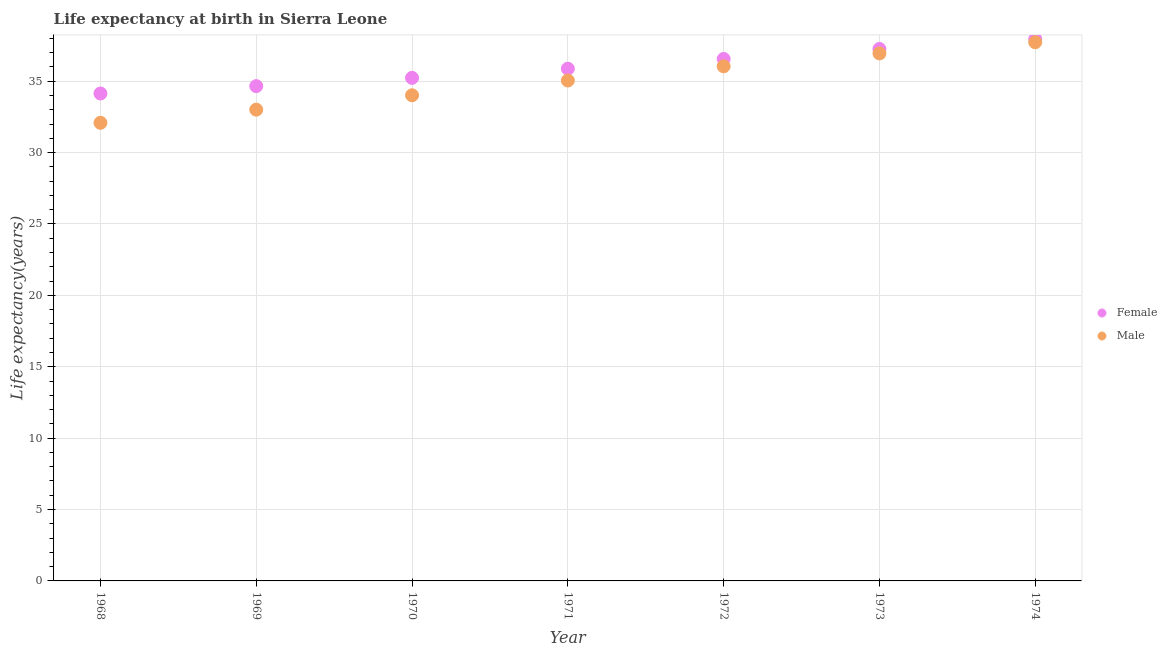What is the life expectancy(female) in 1969?
Give a very brief answer. 34.66. Across all years, what is the maximum life expectancy(male)?
Offer a terse response. 37.73. Across all years, what is the minimum life expectancy(female)?
Make the answer very short. 34.14. In which year was the life expectancy(male) maximum?
Give a very brief answer. 1974. In which year was the life expectancy(male) minimum?
Offer a terse response. 1968. What is the total life expectancy(female) in the graph?
Your answer should be compact. 251.67. What is the difference between the life expectancy(female) in 1968 and that in 1970?
Offer a terse response. -1.1. What is the difference between the life expectancy(male) in 1972 and the life expectancy(female) in 1970?
Offer a very short reply. 0.81. What is the average life expectancy(male) per year?
Offer a terse response. 34.98. In the year 1970, what is the difference between the life expectancy(male) and life expectancy(female)?
Give a very brief answer. -1.22. What is the ratio of the life expectancy(male) in 1968 to that in 1969?
Ensure brevity in your answer.  0.97. Is the life expectancy(female) in 1968 less than that in 1971?
Your response must be concise. Yes. Is the difference between the life expectancy(male) in 1970 and 1971 greater than the difference between the life expectancy(female) in 1970 and 1971?
Offer a terse response. No. What is the difference between the highest and the second highest life expectancy(male)?
Your response must be concise. 0.78. What is the difference between the highest and the lowest life expectancy(male)?
Make the answer very short. 5.64. Is the life expectancy(female) strictly greater than the life expectancy(male) over the years?
Your answer should be very brief. Yes. Is the life expectancy(male) strictly less than the life expectancy(female) over the years?
Give a very brief answer. Yes. How many dotlines are there?
Offer a terse response. 2. How many years are there in the graph?
Provide a succinct answer. 7. Does the graph contain any zero values?
Offer a terse response. No. Does the graph contain grids?
Give a very brief answer. Yes. How are the legend labels stacked?
Ensure brevity in your answer.  Vertical. What is the title of the graph?
Offer a very short reply. Life expectancy at birth in Sierra Leone. What is the label or title of the Y-axis?
Your response must be concise. Life expectancy(years). What is the Life expectancy(years) in Female in 1968?
Give a very brief answer. 34.14. What is the Life expectancy(years) in Male in 1968?
Your answer should be very brief. 32.09. What is the Life expectancy(years) in Female in 1969?
Your response must be concise. 34.66. What is the Life expectancy(years) of Male in 1969?
Provide a short and direct response. 33.01. What is the Life expectancy(years) of Female in 1970?
Provide a succinct answer. 35.23. What is the Life expectancy(years) in Male in 1970?
Your response must be concise. 34.01. What is the Life expectancy(years) of Female in 1971?
Your answer should be compact. 35.88. What is the Life expectancy(years) in Male in 1971?
Your answer should be compact. 35.05. What is the Life expectancy(years) in Female in 1972?
Your answer should be compact. 36.56. What is the Life expectancy(years) in Male in 1972?
Your response must be concise. 36.05. What is the Life expectancy(years) in Female in 1973?
Provide a succinct answer. 37.26. What is the Life expectancy(years) in Male in 1973?
Your answer should be very brief. 36.95. What is the Life expectancy(years) in Female in 1974?
Provide a succinct answer. 37.95. What is the Life expectancy(years) of Male in 1974?
Your answer should be very brief. 37.73. Across all years, what is the maximum Life expectancy(years) of Female?
Provide a short and direct response. 37.95. Across all years, what is the maximum Life expectancy(years) of Male?
Ensure brevity in your answer.  37.73. Across all years, what is the minimum Life expectancy(years) in Female?
Make the answer very short. 34.14. Across all years, what is the minimum Life expectancy(years) in Male?
Offer a terse response. 32.09. What is the total Life expectancy(years) of Female in the graph?
Offer a terse response. 251.67. What is the total Life expectancy(years) in Male in the graph?
Provide a succinct answer. 244.87. What is the difference between the Life expectancy(years) of Female in 1968 and that in 1969?
Offer a terse response. -0.52. What is the difference between the Life expectancy(years) in Male in 1968 and that in 1969?
Offer a terse response. -0.92. What is the difference between the Life expectancy(years) of Female in 1968 and that in 1970?
Your answer should be compact. -1.1. What is the difference between the Life expectancy(years) in Male in 1968 and that in 1970?
Your response must be concise. -1.93. What is the difference between the Life expectancy(years) in Female in 1968 and that in 1971?
Provide a short and direct response. -1.74. What is the difference between the Life expectancy(years) of Male in 1968 and that in 1971?
Make the answer very short. -2.96. What is the difference between the Life expectancy(years) of Female in 1968 and that in 1972?
Offer a terse response. -2.42. What is the difference between the Life expectancy(years) in Male in 1968 and that in 1972?
Ensure brevity in your answer.  -3.96. What is the difference between the Life expectancy(years) of Female in 1968 and that in 1973?
Ensure brevity in your answer.  -3.12. What is the difference between the Life expectancy(years) of Male in 1968 and that in 1973?
Offer a very short reply. -4.86. What is the difference between the Life expectancy(years) of Female in 1968 and that in 1974?
Your response must be concise. -3.81. What is the difference between the Life expectancy(years) in Male in 1968 and that in 1974?
Offer a terse response. -5.64. What is the difference between the Life expectancy(years) of Female in 1969 and that in 1970?
Offer a very short reply. -0.58. What is the difference between the Life expectancy(years) in Male in 1969 and that in 1970?
Give a very brief answer. -1.01. What is the difference between the Life expectancy(years) in Female in 1969 and that in 1971?
Keep it short and to the point. -1.22. What is the difference between the Life expectancy(years) of Male in 1969 and that in 1971?
Give a very brief answer. -2.04. What is the difference between the Life expectancy(years) of Female in 1969 and that in 1972?
Offer a terse response. -1.9. What is the difference between the Life expectancy(years) in Male in 1969 and that in 1972?
Your response must be concise. -3.04. What is the difference between the Life expectancy(years) in Female in 1969 and that in 1973?
Give a very brief answer. -2.6. What is the difference between the Life expectancy(years) of Male in 1969 and that in 1973?
Provide a short and direct response. -3.94. What is the difference between the Life expectancy(years) in Female in 1969 and that in 1974?
Provide a succinct answer. -3.3. What is the difference between the Life expectancy(years) of Male in 1969 and that in 1974?
Your answer should be very brief. -4.72. What is the difference between the Life expectancy(years) in Female in 1970 and that in 1971?
Provide a succinct answer. -0.64. What is the difference between the Life expectancy(years) of Male in 1970 and that in 1971?
Your response must be concise. -1.03. What is the difference between the Life expectancy(years) in Female in 1970 and that in 1972?
Ensure brevity in your answer.  -1.32. What is the difference between the Life expectancy(years) of Male in 1970 and that in 1972?
Offer a very short reply. -2.03. What is the difference between the Life expectancy(years) in Female in 1970 and that in 1973?
Give a very brief answer. -2.02. What is the difference between the Life expectancy(years) in Male in 1970 and that in 1973?
Your answer should be very brief. -2.94. What is the difference between the Life expectancy(years) of Female in 1970 and that in 1974?
Your answer should be very brief. -2.72. What is the difference between the Life expectancy(years) in Male in 1970 and that in 1974?
Your answer should be compact. -3.71. What is the difference between the Life expectancy(years) of Female in 1971 and that in 1972?
Your answer should be compact. -0.68. What is the difference between the Life expectancy(years) of Male in 1971 and that in 1972?
Your response must be concise. -1. What is the difference between the Life expectancy(years) of Female in 1971 and that in 1973?
Your answer should be compact. -1.38. What is the difference between the Life expectancy(years) in Male in 1971 and that in 1973?
Offer a very short reply. -1.9. What is the difference between the Life expectancy(years) of Female in 1971 and that in 1974?
Your answer should be very brief. -2.08. What is the difference between the Life expectancy(years) of Male in 1971 and that in 1974?
Your response must be concise. -2.68. What is the difference between the Life expectancy(years) in Male in 1972 and that in 1973?
Make the answer very short. -0.9. What is the difference between the Life expectancy(years) in Female in 1972 and that in 1974?
Offer a terse response. -1.39. What is the difference between the Life expectancy(years) in Male in 1972 and that in 1974?
Your answer should be very brief. -1.68. What is the difference between the Life expectancy(years) in Female in 1973 and that in 1974?
Ensure brevity in your answer.  -0.69. What is the difference between the Life expectancy(years) of Male in 1973 and that in 1974?
Provide a short and direct response. -0.78. What is the difference between the Life expectancy(years) in Female in 1968 and the Life expectancy(years) in Male in 1969?
Your answer should be compact. 1.13. What is the difference between the Life expectancy(years) in Female in 1968 and the Life expectancy(years) in Male in 1970?
Ensure brevity in your answer.  0.13. What is the difference between the Life expectancy(years) of Female in 1968 and the Life expectancy(years) of Male in 1971?
Provide a short and direct response. -0.91. What is the difference between the Life expectancy(years) in Female in 1968 and the Life expectancy(years) in Male in 1972?
Keep it short and to the point. -1.91. What is the difference between the Life expectancy(years) of Female in 1968 and the Life expectancy(years) of Male in 1973?
Provide a short and direct response. -2.81. What is the difference between the Life expectancy(years) in Female in 1968 and the Life expectancy(years) in Male in 1974?
Provide a succinct answer. -3.59. What is the difference between the Life expectancy(years) in Female in 1969 and the Life expectancy(years) in Male in 1970?
Ensure brevity in your answer.  0.64. What is the difference between the Life expectancy(years) of Female in 1969 and the Life expectancy(years) of Male in 1971?
Your response must be concise. -0.39. What is the difference between the Life expectancy(years) in Female in 1969 and the Life expectancy(years) in Male in 1972?
Your response must be concise. -1.39. What is the difference between the Life expectancy(years) in Female in 1969 and the Life expectancy(years) in Male in 1973?
Provide a succinct answer. -2.29. What is the difference between the Life expectancy(years) of Female in 1969 and the Life expectancy(years) of Male in 1974?
Make the answer very short. -3.07. What is the difference between the Life expectancy(years) in Female in 1970 and the Life expectancy(years) in Male in 1971?
Offer a very short reply. 0.19. What is the difference between the Life expectancy(years) in Female in 1970 and the Life expectancy(years) in Male in 1972?
Provide a succinct answer. -0.81. What is the difference between the Life expectancy(years) of Female in 1970 and the Life expectancy(years) of Male in 1973?
Offer a terse response. -1.71. What is the difference between the Life expectancy(years) of Female in 1970 and the Life expectancy(years) of Male in 1974?
Your response must be concise. -2.49. What is the difference between the Life expectancy(years) in Female in 1971 and the Life expectancy(years) in Male in 1972?
Your response must be concise. -0.17. What is the difference between the Life expectancy(years) of Female in 1971 and the Life expectancy(years) of Male in 1973?
Your answer should be very brief. -1.07. What is the difference between the Life expectancy(years) of Female in 1971 and the Life expectancy(years) of Male in 1974?
Offer a very short reply. -1.85. What is the difference between the Life expectancy(years) of Female in 1972 and the Life expectancy(years) of Male in 1973?
Give a very brief answer. -0.39. What is the difference between the Life expectancy(years) in Female in 1972 and the Life expectancy(years) in Male in 1974?
Make the answer very short. -1.17. What is the difference between the Life expectancy(years) in Female in 1973 and the Life expectancy(years) in Male in 1974?
Provide a short and direct response. -0.47. What is the average Life expectancy(years) in Female per year?
Offer a terse response. 35.95. What is the average Life expectancy(years) in Male per year?
Keep it short and to the point. 34.98. In the year 1968, what is the difference between the Life expectancy(years) in Female and Life expectancy(years) in Male?
Keep it short and to the point. 2.05. In the year 1969, what is the difference between the Life expectancy(years) of Female and Life expectancy(years) of Male?
Offer a very short reply. 1.65. In the year 1970, what is the difference between the Life expectancy(years) of Female and Life expectancy(years) of Male?
Provide a short and direct response. 1.22. In the year 1971, what is the difference between the Life expectancy(years) of Female and Life expectancy(years) of Male?
Offer a very short reply. 0.83. In the year 1972, what is the difference between the Life expectancy(years) of Female and Life expectancy(years) of Male?
Your response must be concise. 0.51. In the year 1973, what is the difference between the Life expectancy(years) of Female and Life expectancy(years) of Male?
Provide a short and direct response. 0.31. In the year 1974, what is the difference between the Life expectancy(years) in Female and Life expectancy(years) in Male?
Give a very brief answer. 0.22. What is the ratio of the Life expectancy(years) in Female in 1968 to that in 1969?
Offer a terse response. 0.99. What is the ratio of the Life expectancy(years) of Male in 1968 to that in 1969?
Offer a very short reply. 0.97. What is the ratio of the Life expectancy(years) in Female in 1968 to that in 1970?
Offer a terse response. 0.97. What is the ratio of the Life expectancy(years) in Male in 1968 to that in 1970?
Your answer should be very brief. 0.94. What is the ratio of the Life expectancy(years) of Female in 1968 to that in 1971?
Your answer should be compact. 0.95. What is the ratio of the Life expectancy(years) in Male in 1968 to that in 1971?
Make the answer very short. 0.92. What is the ratio of the Life expectancy(years) in Female in 1968 to that in 1972?
Offer a terse response. 0.93. What is the ratio of the Life expectancy(years) of Male in 1968 to that in 1972?
Your answer should be very brief. 0.89. What is the ratio of the Life expectancy(years) of Female in 1968 to that in 1973?
Make the answer very short. 0.92. What is the ratio of the Life expectancy(years) of Male in 1968 to that in 1973?
Offer a terse response. 0.87. What is the ratio of the Life expectancy(years) in Female in 1968 to that in 1974?
Offer a terse response. 0.9. What is the ratio of the Life expectancy(years) of Male in 1968 to that in 1974?
Your answer should be compact. 0.85. What is the ratio of the Life expectancy(years) in Female in 1969 to that in 1970?
Give a very brief answer. 0.98. What is the ratio of the Life expectancy(years) in Male in 1969 to that in 1970?
Make the answer very short. 0.97. What is the ratio of the Life expectancy(years) in Male in 1969 to that in 1971?
Your response must be concise. 0.94. What is the ratio of the Life expectancy(years) of Female in 1969 to that in 1972?
Provide a succinct answer. 0.95. What is the ratio of the Life expectancy(years) in Male in 1969 to that in 1972?
Give a very brief answer. 0.92. What is the ratio of the Life expectancy(years) in Female in 1969 to that in 1973?
Your answer should be compact. 0.93. What is the ratio of the Life expectancy(years) in Male in 1969 to that in 1973?
Make the answer very short. 0.89. What is the ratio of the Life expectancy(years) of Female in 1969 to that in 1974?
Your answer should be compact. 0.91. What is the ratio of the Life expectancy(years) of Male in 1969 to that in 1974?
Your answer should be compact. 0.87. What is the ratio of the Life expectancy(years) in Female in 1970 to that in 1971?
Your answer should be compact. 0.98. What is the ratio of the Life expectancy(years) of Male in 1970 to that in 1971?
Make the answer very short. 0.97. What is the ratio of the Life expectancy(years) in Female in 1970 to that in 1972?
Keep it short and to the point. 0.96. What is the ratio of the Life expectancy(years) of Male in 1970 to that in 1972?
Provide a succinct answer. 0.94. What is the ratio of the Life expectancy(years) of Female in 1970 to that in 1973?
Offer a very short reply. 0.95. What is the ratio of the Life expectancy(years) of Male in 1970 to that in 1973?
Your answer should be very brief. 0.92. What is the ratio of the Life expectancy(years) in Female in 1970 to that in 1974?
Give a very brief answer. 0.93. What is the ratio of the Life expectancy(years) in Male in 1970 to that in 1974?
Ensure brevity in your answer.  0.9. What is the ratio of the Life expectancy(years) of Female in 1971 to that in 1972?
Your answer should be compact. 0.98. What is the ratio of the Life expectancy(years) of Male in 1971 to that in 1972?
Offer a very short reply. 0.97. What is the ratio of the Life expectancy(years) of Female in 1971 to that in 1973?
Ensure brevity in your answer.  0.96. What is the ratio of the Life expectancy(years) of Male in 1971 to that in 1973?
Offer a terse response. 0.95. What is the ratio of the Life expectancy(years) of Female in 1971 to that in 1974?
Offer a terse response. 0.95. What is the ratio of the Life expectancy(years) of Male in 1971 to that in 1974?
Give a very brief answer. 0.93. What is the ratio of the Life expectancy(years) of Female in 1972 to that in 1973?
Give a very brief answer. 0.98. What is the ratio of the Life expectancy(years) in Male in 1972 to that in 1973?
Offer a terse response. 0.98. What is the ratio of the Life expectancy(years) in Female in 1972 to that in 1974?
Provide a succinct answer. 0.96. What is the ratio of the Life expectancy(years) of Male in 1972 to that in 1974?
Your response must be concise. 0.96. What is the ratio of the Life expectancy(years) of Female in 1973 to that in 1974?
Keep it short and to the point. 0.98. What is the ratio of the Life expectancy(years) of Male in 1973 to that in 1974?
Offer a terse response. 0.98. What is the difference between the highest and the second highest Life expectancy(years) of Female?
Provide a short and direct response. 0.69. What is the difference between the highest and the second highest Life expectancy(years) of Male?
Offer a very short reply. 0.78. What is the difference between the highest and the lowest Life expectancy(years) in Female?
Provide a short and direct response. 3.81. What is the difference between the highest and the lowest Life expectancy(years) of Male?
Your response must be concise. 5.64. 